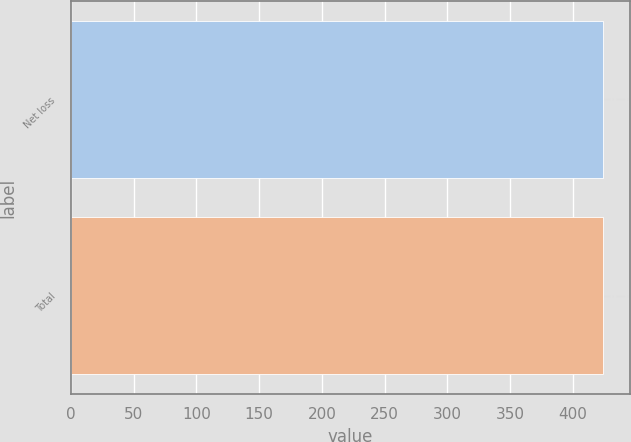Convert chart to OTSL. <chart><loc_0><loc_0><loc_500><loc_500><bar_chart><fcel>Net loss<fcel>Total<nl><fcel>424<fcel>424.1<nl></chart> 